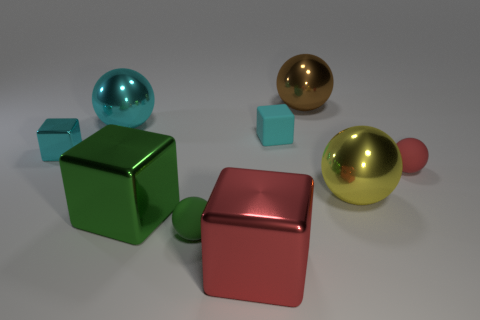Are there an equal number of things to the left of the small cyan matte thing and big cyan shiny things that are to the right of the red ball?
Your answer should be compact. No. There is a cyan thing that is on the right side of the big cyan shiny object; does it have the same shape as the big green metal thing?
Your response must be concise. Yes. Is the shape of the large yellow thing the same as the big brown metallic object?
Offer a very short reply. Yes. What is the material of the tiny cube that is the same color as the small metal thing?
Make the answer very short. Rubber. Is the size of the green block the same as the yellow shiny sphere?
Make the answer very short. Yes. There is a red cube that is the same size as the brown shiny object; what is it made of?
Your answer should be compact. Metal. What material is the block that is both in front of the small red thing and behind the red cube?
Provide a short and direct response. Metal. There is a shiny thing that is in front of the tiny cyan matte object and on the right side of the large red metallic thing; what is its size?
Make the answer very short. Large. There is a cyan shiny thing that is the same size as the brown metallic thing; what is its shape?
Provide a short and direct response. Sphere. Is the small object that is in front of the small red rubber object made of the same material as the brown ball?
Offer a terse response. No. 